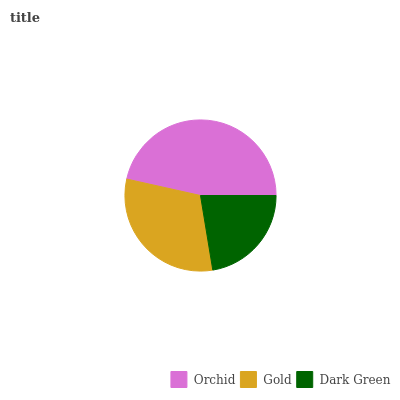Is Dark Green the minimum?
Answer yes or no. Yes. Is Orchid the maximum?
Answer yes or no. Yes. Is Gold the minimum?
Answer yes or no. No. Is Gold the maximum?
Answer yes or no. No. Is Orchid greater than Gold?
Answer yes or no. Yes. Is Gold less than Orchid?
Answer yes or no. Yes. Is Gold greater than Orchid?
Answer yes or no. No. Is Orchid less than Gold?
Answer yes or no. No. Is Gold the high median?
Answer yes or no. Yes. Is Gold the low median?
Answer yes or no. Yes. Is Dark Green the high median?
Answer yes or no. No. Is Orchid the low median?
Answer yes or no. No. 